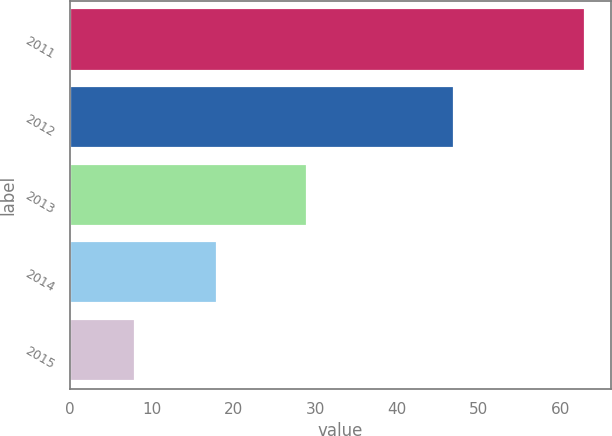Convert chart to OTSL. <chart><loc_0><loc_0><loc_500><loc_500><bar_chart><fcel>2011<fcel>2012<fcel>2013<fcel>2014<fcel>2015<nl><fcel>63<fcel>47<fcel>29<fcel>18<fcel>8<nl></chart> 